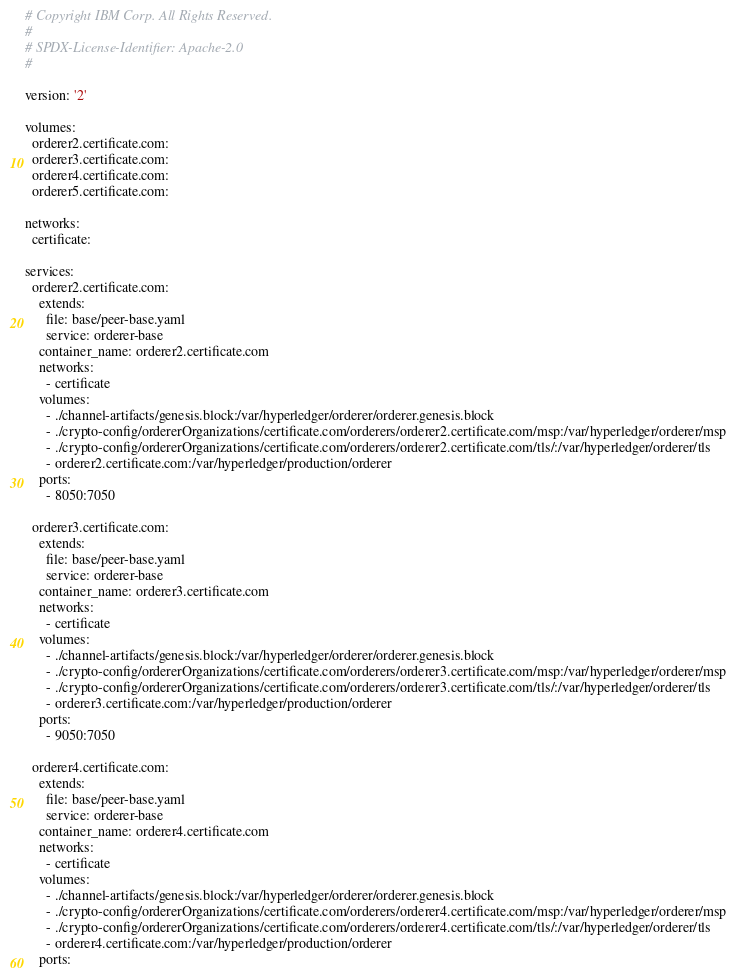<code> <loc_0><loc_0><loc_500><loc_500><_YAML_># Copyright IBM Corp. All Rights Reserved.
#
# SPDX-License-Identifier: Apache-2.0
#

version: '2'

volumes:
  orderer2.certificate.com:
  orderer3.certificate.com:
  orderer4.certificate.com:
  orderer5.certificate.com:

networks:
  certificate:

services:
  orderer2.certificate.com:
    extends:
      file: base/peer-base.yaml
      service: orderer-base
    container_name: orderer2.certificate.com
    networks:
      - certificate
    volumes:
      - ./channel-artifacts/genesis.block:/var/hyperledger/orderer/orderer.genesis.block
      - ./crypto-config/ordererOrganizations/certificate.com/orderers/orderer2.certificate.com/msp:/var/hyperledger/orderer/msp
      - ./crypto-config/ordererOrganizations/certificate.com/orderers/orderer2.certificate.com/tls/:/var/hyperledger/orderer/tls
      - orderer2.certificate.com:/var/hyperledger/production/orderer
    ports:
      - 8050:7050

  orderer3.certificate.com:
    extends:
      file: base/peer-base.yaml
      service: orderer-base
    container_name: orderer3.certificate.com
    networks:
      - certificate
    volumes:
      - ./channel-artifacts/genesis.block:/var/hyperledger/orderer/orderer.genesis.block
      - ./crypto-config/ordererOrganizations/certificate.com/orderers/orderer3.certificate.com/msp:/var/hyperledger/orderer/msp
      - ./crypto-config/ordererOrganizations/certificate.com/orderers/orderer3.certificate.com/tls/:/var/hyperledger/orderer/tls
      - orderer3.certificate.com:/var/hyperledger/production/orderer
    ports:
      - 9050:7050

  orderer4.certificate.com:
    extends:
      file: base/peer-base.yaml
      service: orderer-base
    container_name: orderer4.certificate.com
    networks:
      - certificate
    volumes:
      - ./channel-artifacts/genesis.block:/var/hyperledger/orderer/orderer.genesis.block
      - ./crypto-config/ordererOrganizations/certificate.com/orderers/orderer4.certificate.com/msp:/var/hyperledger/orderer/msp
      - ./crypto-config/ordererOrganizations/certificate.com/orderers/orderer4.certificate.com/tls/:/var/hyperledger/orderer/tls
      - orderer4.certificate.com:/var/hyperledger/production/orderer
    ports:</code> 